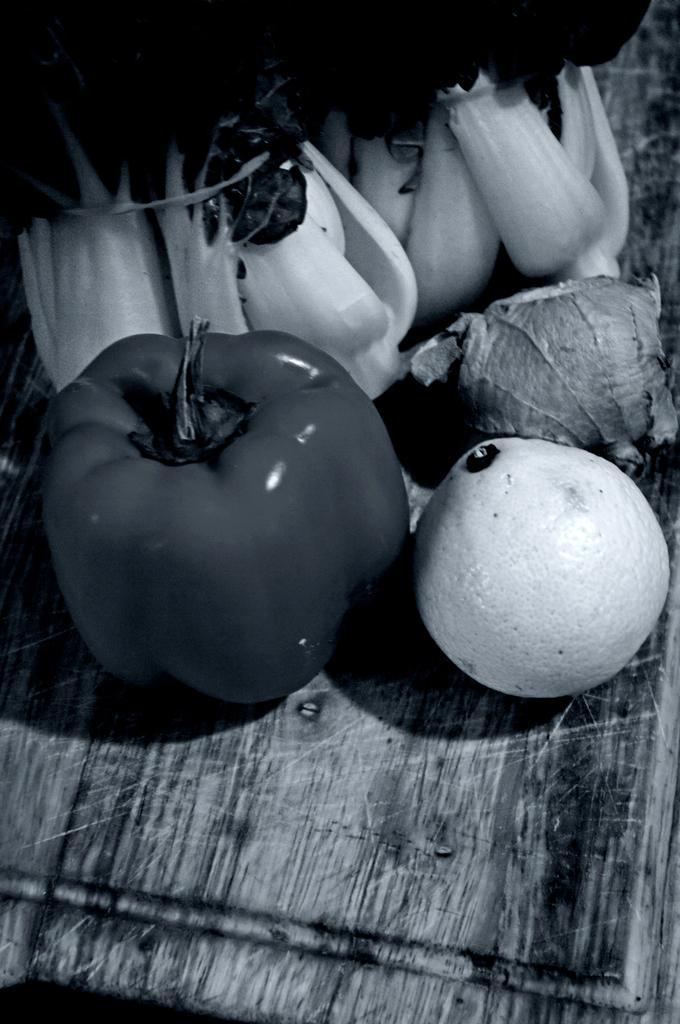Describe this image in one or two sentences. This is a black and white image. In this image there is a capsicum and some other vegetables. 